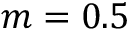<formula> <loc_0><loc_0><loc_500><loc_500>m = 0 . 5</formula> 